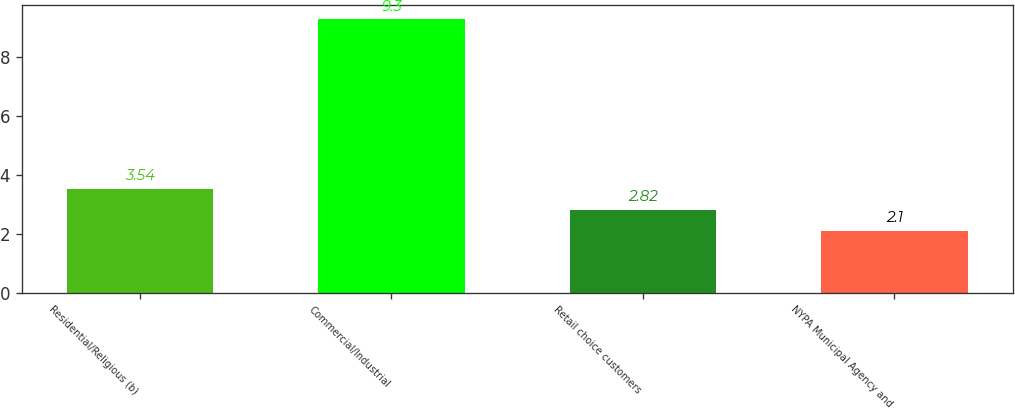<chart> <loc_0><loc_0><loc_500><loc_500><bar_chart><fcel>Residential/Religious (b)<fcel>Commercial/Industrial<fcel>Retail choice customers<fcel>NYPA Municipal Agency and<nl><fcel>3.54<fcel>9.3<fcel>2.82<fcel>2.1<nl></chart> 